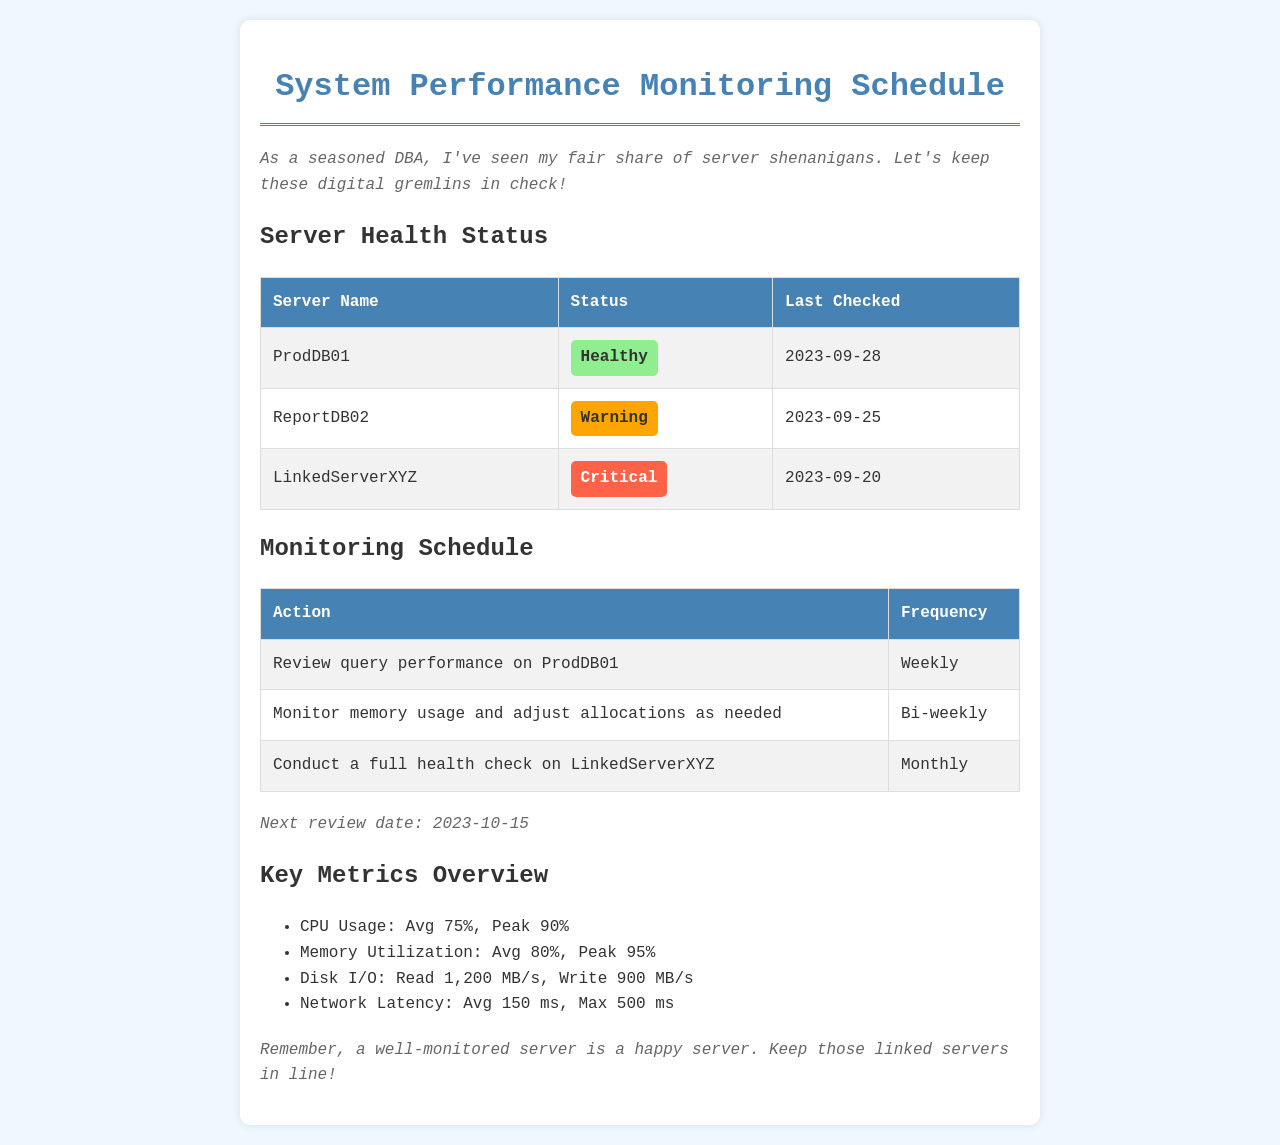What is the status of ProdDB01? The status of ProdDB01 is listed in the server health status section of the document, marked as Healthy.
Answer: Healthy When was LinkedServerXYZ last checked? The last checked date for LinkedServerXYZ is provided in the server health status table. It was last checked on September 20, 2023.
Answer: 2023-09-20 How often is query performance on ProdDB01 reviewed? The frequency of reviewing query performance on ProdDB01 is stated in the monitoring schedule. It occurs weekly.
Answer: Weekly What is the average CPU usage? The average CPU usage metric is given in the key metrics overview section of the document, noted as 75%.
Answer: 75% How often is a full health check conducted on LinkedServerXYZ? The frequency of the full health check on LinkedServerXYZ is specified in the monitoring schedule. It is conducted monthly.
Answer: Monthly What was the peak memory utilization? The peak memory utilization is detailed in the key metrics overview, indicating the highest usage reached 95%.
Answer: 95% What is the next review date? The next review date for the system performance monitoring is mentioned in the notes section of the document. It is scheduled for October 15, 2023.
Answer: 2023-10-15 What is the disk I/O write rate? The write rate for disk I/O is stated in the key metrics overview as 900 MB/s.
Answer: 900 MB/s What server has a critical status? The server with a critical status is identified in the server health status table as LinkedServerXYZ.
Answer: LinkedServerXYZ 